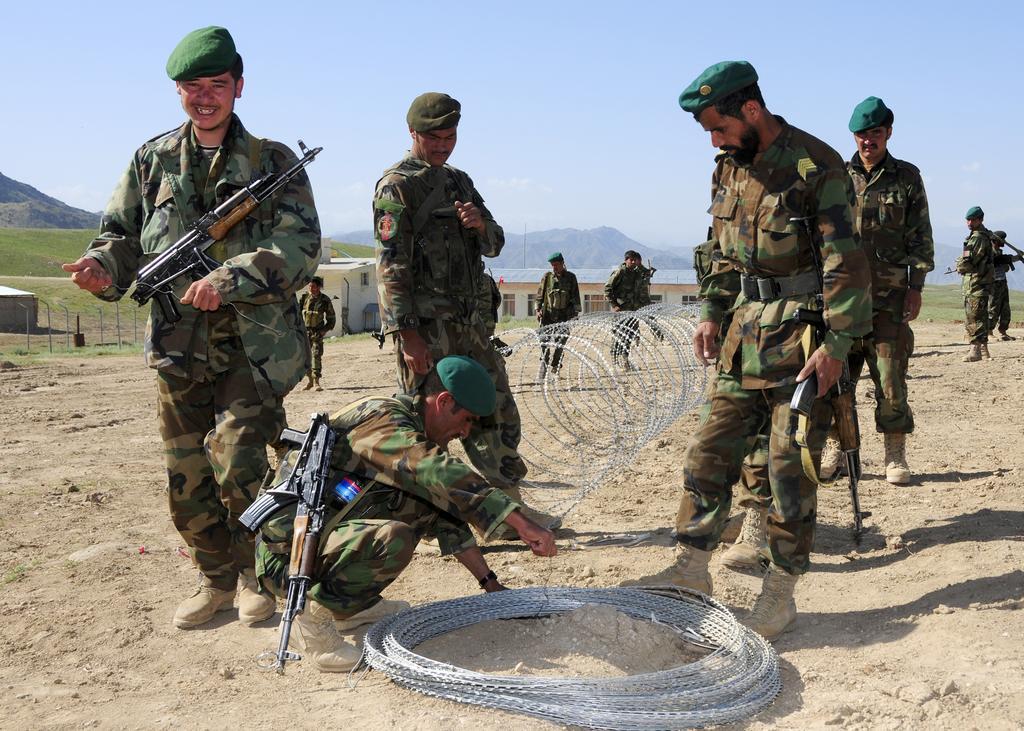Could you give a brief overview of what you see in this image? In this image we can see a group of people wearing military dress and caps is standing on the ground. One person is holding a gun in his hand. One person is holding a wire in his hand. In the background, we can see a building with windows, a fence and group of mountains and the sky. 